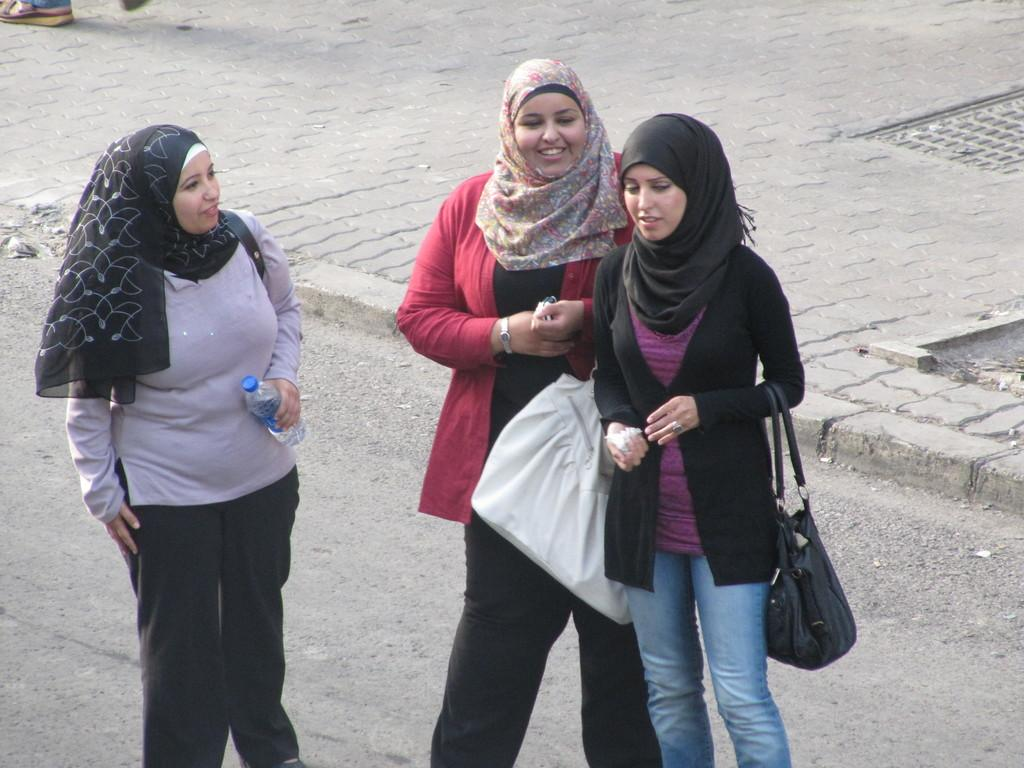How many people are in the image? There are three persons standing in the image. What is one person holding in the image? One person is holding a bottle. What can be seen in the background of the image? There is a road visible in the image. What type of pen is being used to write on the road in the image? There is no pen or writing visible on the road in the image. 